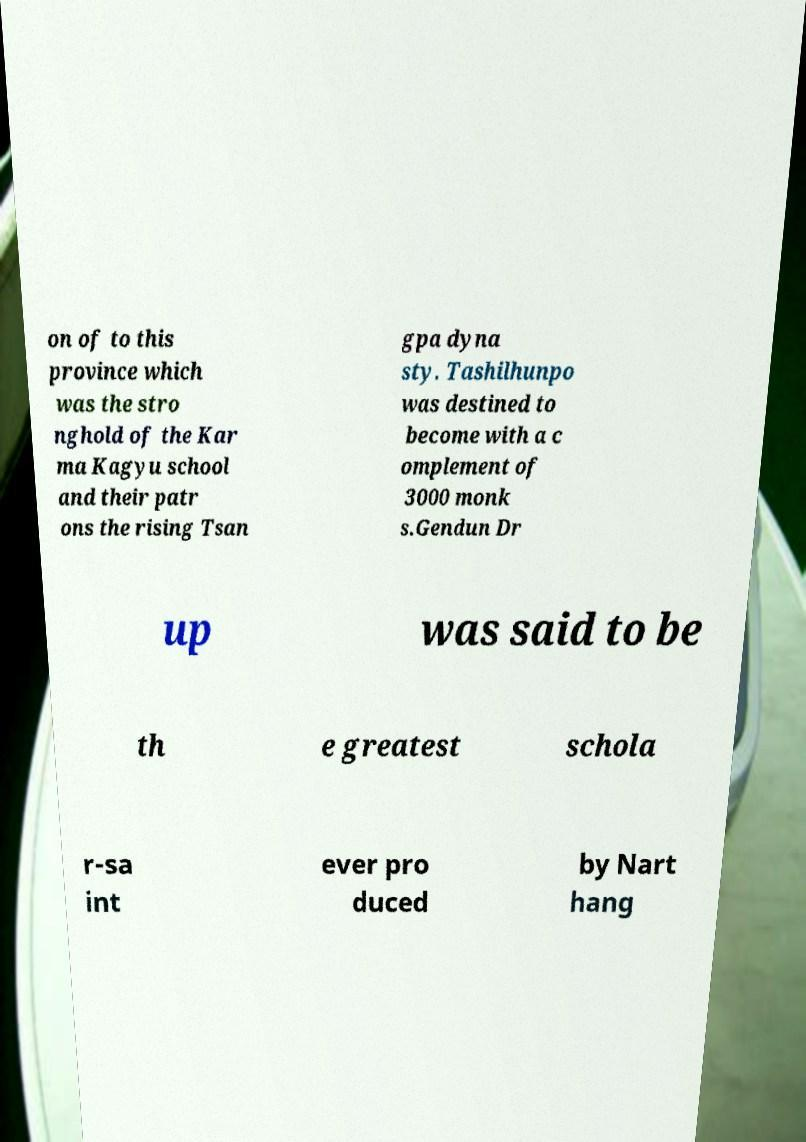Can you read and provide the text displayed in the image?This photo seems to have some interesting text. Can you extract and type it out for me? on of to this province which was the stro nghold of the Kar ma Kagyu school and their patr ons the rising Tsan gpa dyna sty. Tashilhunpo was destined to become with a c omplement of 3000 monk s.Gendun Dr up was said to be th e greatest schola r-sa int ever pro duced by Nart hang 